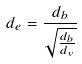Convert formula to latex. <formula><loc_0><loc_0><loc_500><loc_500>d _ { e } = \frac { d _ { b } } { \sqrt { \frac { d _ { b } } { d _ { v } } } }</formula> 